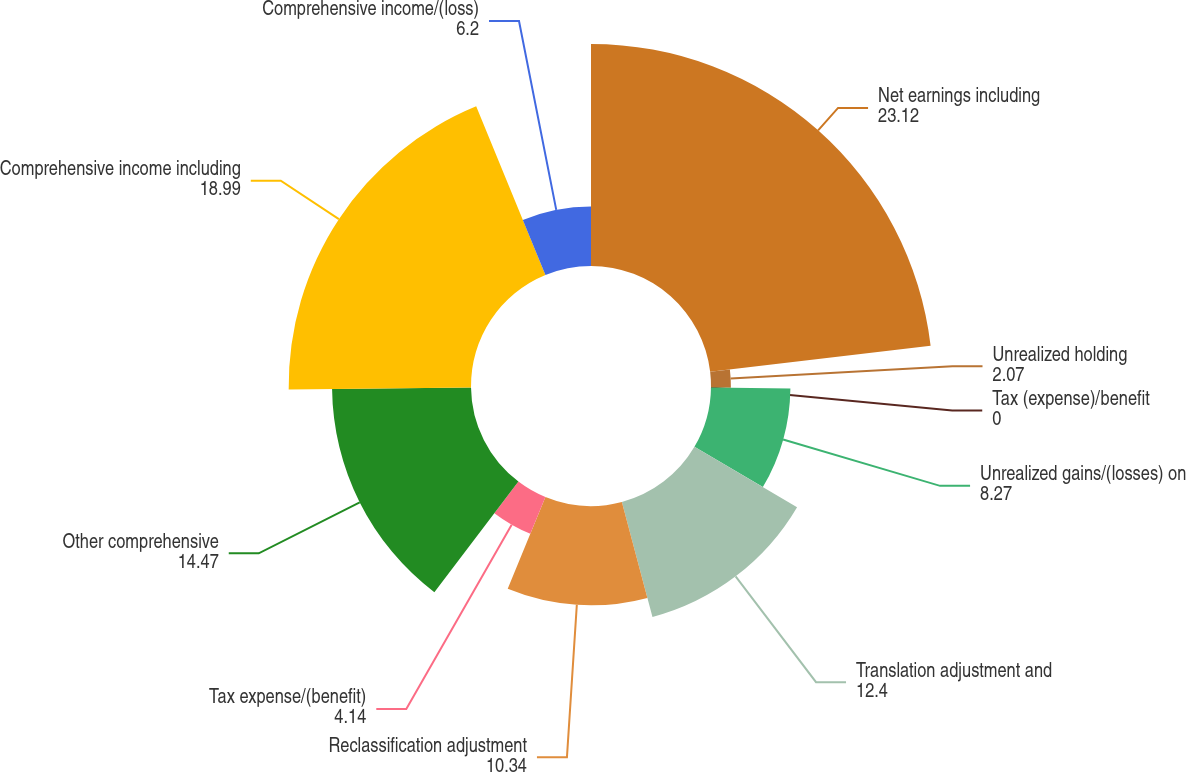<chart> <loc_0><loc_0><loc_500><loc_500><pie_chart><fcel>Net earnings including<fcel>Unrealized holding<fcel>Tax (expense)/benefit<fcel>Unrealized gains/(losses) on<fcel>Translation adjustment and<fcel>Reclassification adjustment<fcel>Tax expense/(benefit)<fcel>Other comprehensive<fcel>Comprehensive income including<fcel>Comprehensive income/(loss)<nl><fcel>23.12%<fcel>2.07%<fcel>0.0%<fcel>8.27%<fcel>12.4%<fcel>10.34%<fcel>4.14%<fcel>14.47%<fcel>18.99%<fcel>6.2%<nl></chart> 